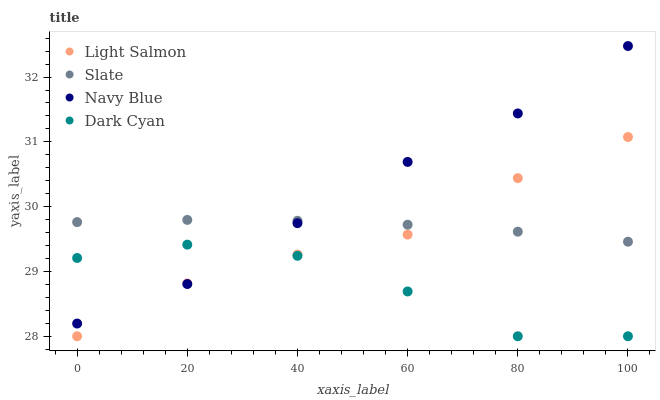Does Dark Cyan have the minimum area under the curve?
Answer yes or no. Yes. Does Navy Blue have the maximum area under the curve?
Answer yes or no. Yes. Does Light Salmon have the minimum area under the curve?
Answer yes or no. No. Does Light Salmon have the maximum area under the curve?
Answer yes or no. No. Is Slate the smoothest?
Answer yes or no. Yes. Is Dark Cyan the roughest?
Answer yes or no. Yes. Is Navy Blue the smoothest?
Answer yes or no. No. Is Navy Blue the roughest?
Answer yes or no. No. Does Dark Cyan have the lowest value?
Answer yes or no. Yes. Does Navy Blue have the lowest value?
Answer yes or no. No. Does Navy Blue have the highest value?
Answer yes or no. Yes. Does Light Salmon have the highest value?
Answer yes or no. No. Is Dark Cyan less than Slate?
Answer yes or no. Yes. Is Slate greater than Dark Cyan?
Answer yes or no. Yes. Does Navy Blue intersect Light Salmon?
Answer yes or no. Yes. Is Navy Blue less than Light Salmon?
Answer yes or no. No. Is Navy Blue greater than Light Salmon?
Answer yes or no. No. Does Dark Cyan intersect Slate?
Answer yes or no. No. 